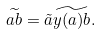<formula> <loc_0><loc_0><loc_500><loc_500>\widetilde { a b } = \tilde { a } \widetilde { y ( a ) b } .</formula> 